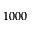Convert formula to latex. <formula><loc_0><loc_0><loc_500><loc_500>1 0 0 0</formula> 